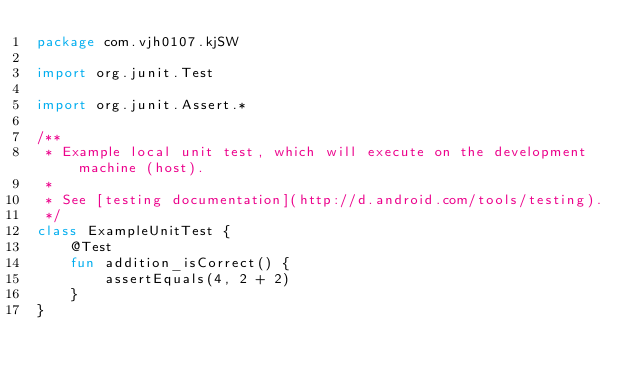<code> <loc_0><loc_0><loc_500><loc_500><_Kotlin_>package com.vjh0107.kjSW

import org.junit.Test

import org.junit.Assert.*

/**
 * Example local unit test, which will execute on the development machine (host).
 *
 * See [testing documentation](http://d.android.com/tools/testing).
 */
class ExampleUnitTest {
    @Test
    fun addition_isCorrect() {
        assertEquals(4, 2 + 2)
    }
}</code> 